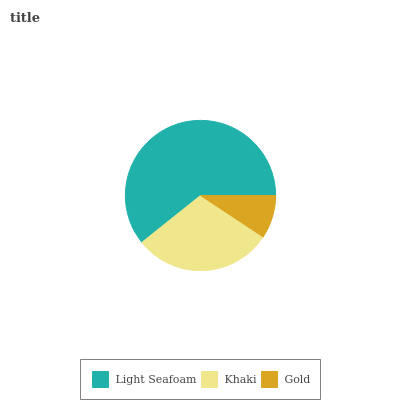Is Gold the minimum?
Answer yes or no. Yes. Is Light Seafoam the maximum?
Answer yes or no. Yes. Is Khaki the minimum?
Answer yes or no. No. Is Khaki the maximum?
Answer yes or no. No. Is Light Seafoam greater than Khaki?
Answer yes or no. Yes. Is Khaki less than Light Seafoam?
Answer yes or no. Yes. Is Khaki greater than Light Seafoam?
Answer yes or no. No. Is Light Seafoam less than Khaki?
Answer yes or no. No. Is Khaki the high median?
Answer yes or no. Yes. Is Khaki the low median?
Answer yes or no. Yes. Is Light Seafoam the high median?
Answer yes or no. No. Is Light Seafoam the low median?
Answer yes or no. No. 